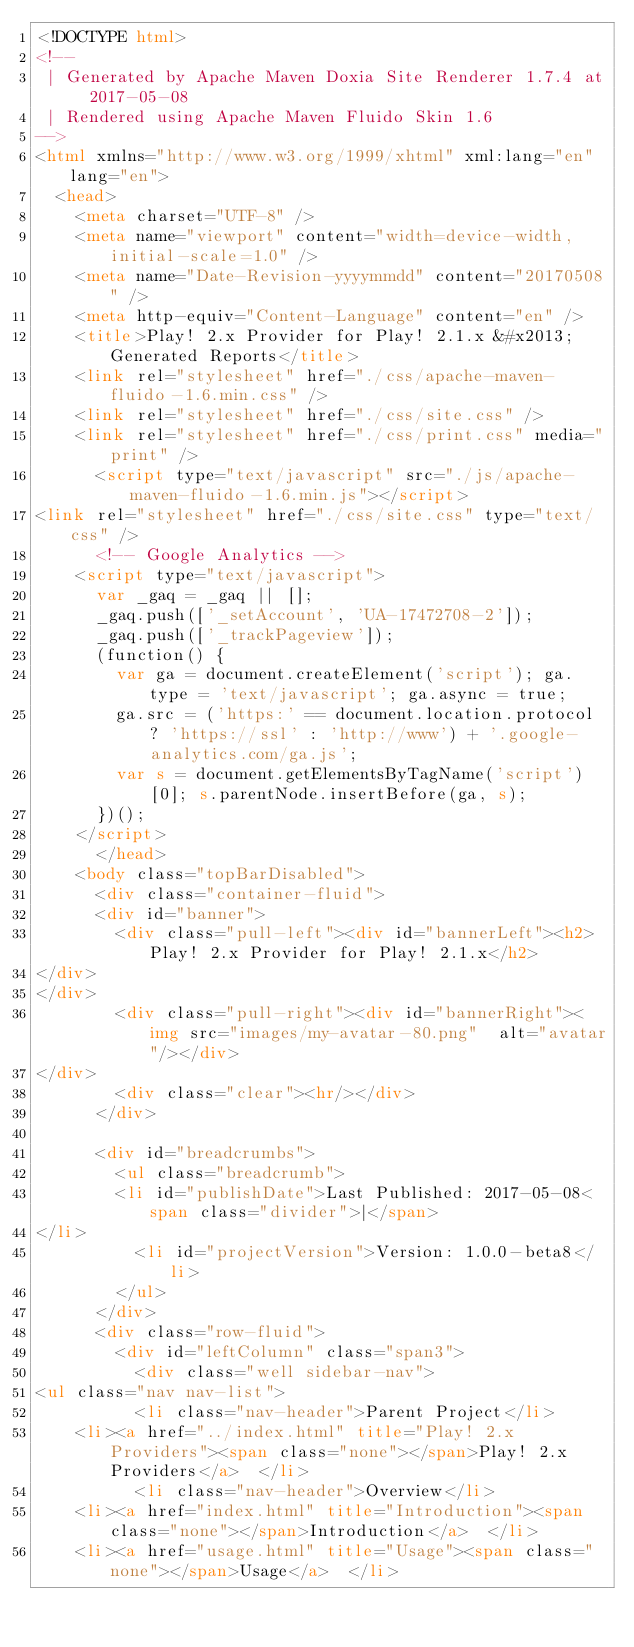<code> <loc_0><loc_0><loc_500><loc_500><_HTML_><!DOCTYPE html>
<!--
 | Generated by Apache Maven Doxia Site Renderer 1.7.4 at 2017-05-08 
 | Rendered using Apache Maven Fluido Skin 1.6
-->
<html xmlns="http://www.w3.org/1999/xhtml" xml:lang="en" lang="en">
  <head>
    <meta charset="UTF-8" />
    <meta name="viewport" content="width=device-width, initial-scale=1.0" />
    <meta name="Date-Revision-yyyymmdd" content="20170508" />
    <meta http-equiv="Content-Language" content="en" />
    <title>Play! 2.x Provider for Play! 2.1.x &#x2013; Generated Reports</title>
    <link rel="stylesheet" href="./css/apache-maven-fluido-1.6.min.css" />
    <link rel="stylesheet" href="./css/site.css" />
    <link rel="stylesheet" href="./css/print.css" media="print" />
      <script type="text/javascript" src="./js/apache-maven-fluido-1.6.min.js"></script>
<link rel="stylesheet" href="./css/site.css" type="text/css" />
      <!-- Google Analytics -->
    <script type="text/javascript">
      var _gaq = _gaq || [];
      _gaq.push(['_setAccount', 'UA-17472708-2']);
      _gaq.push(['_trackPageview']);
      (function() {
        var ga = document.createElement('script'); ga.type = 'text/javascript'; ga.async = true;
        ga.src = ('https:' == document.location.protocol ? 'https://ssl' : 'http://www') + '.google-analytics.com/ga.js';
        var s = document.getElementsByTagName('script')[0]; s.parentNode.insertBefore(ga, s);
      })();
    </script>
      </head>
    <body class="topBarDisabled">
      <div class="container-fluid">
      <div id="banner">
        <div class="pull-left"><div id="bannerLeft"><h2>Play! 2.x Provider for Play! 2.1.x</h2>
</div>
</div>
        <div class="pull-right"><div id="bannerRight"><img src="images/my-avatar-80.png"  alt="avatar"/></div>
</div>
        <div class="clear"><hr/></div>
      </div>

      <div id="breadcrumbs">
        <ul class="breadcrumb">
        <li id="publishDate">Last Published: 2017-05-08<span class="divider">|</span>
</li>
          <li id="projectVersion">Version: 1.0.0-beta8</li>
        </ul>
      </div>
      <div class="row-fluid">
        <div id="leftColumn" class="span3">
          <div class="well sidebar-nav">
<ul class="nav nav-list">
          <li class="nav-header">Parent Project</li>
    <li><a href="../index.html" title="Play! 2.x Providers"><span class="none"></span>Play! 2.x Providers</a>  </li>
          <li class="nav-header">Overview</li>
    <li><a href="index.html" title="Introduction"><span class="none"></span>Introduction</a>  </li>
    <li><a href="usage.html" title="Usage"><span class="none"></span>Usage</a>  </li></code> 